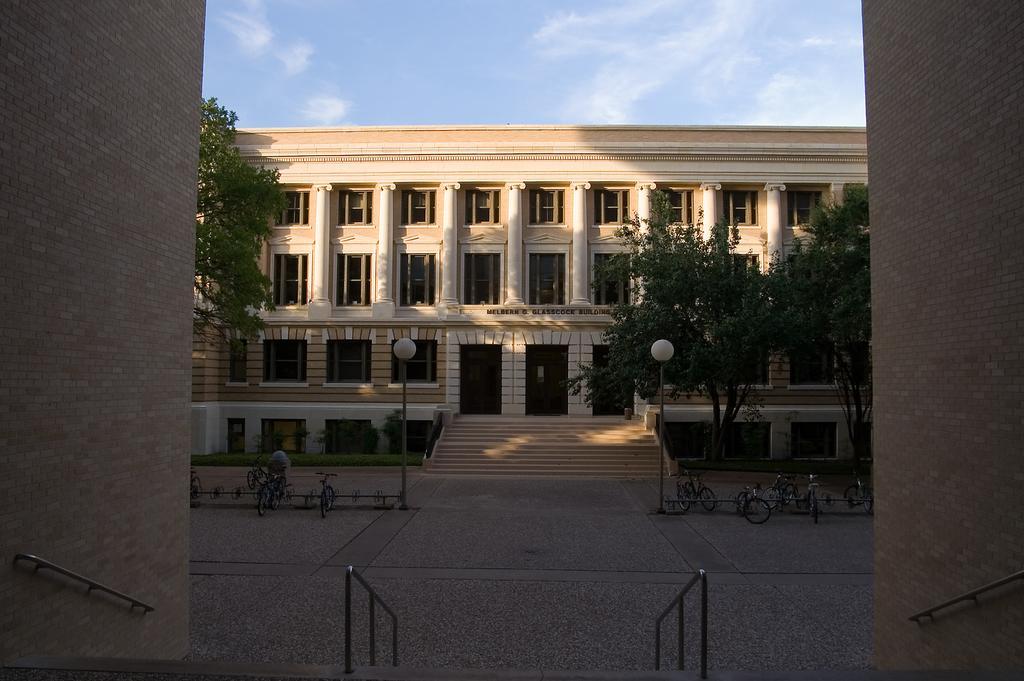Please provide a concise description of this image. In this image there is a big building in front of that there are so many trees, street light poles and bicycles parked on the road. 